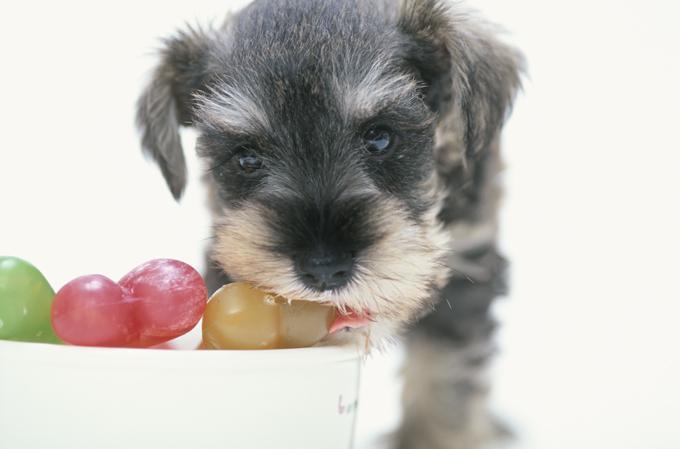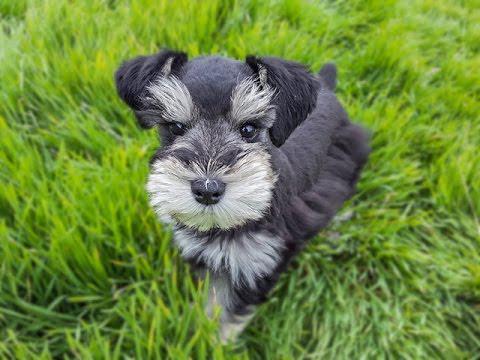The first image is the image on the left, the second image is the image on the right. Assess this claim about the two images: "One schnauzer puppy is sitting on its bottom.". Correct or not? Answer yes or no. No. 